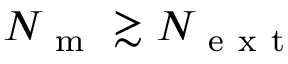Convert formula to latex. <formula><loc_0><loc_0><loc_500><loc_500>N _ { m } \gtrsim N _ { e x t }</formula> 